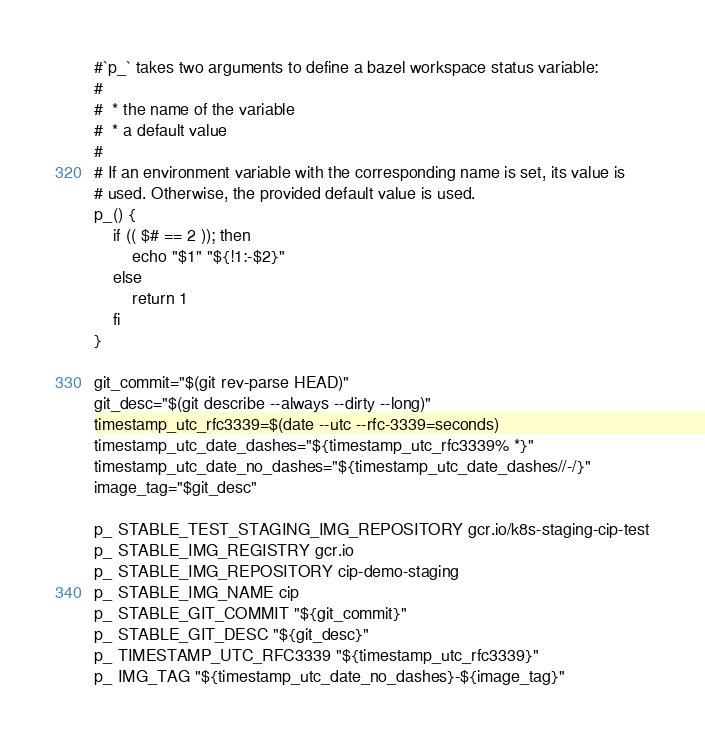<code> <loc_0><loc_0><loc_500><loc_500><_Bash_>
#`p_` takes two arguments to define a bazel workspace status variable:
#
#  * the name of the variable
#  * a default value
#
# If an environment variable with the corresponding name is set, its value is
# used. Otherwise, the provided default value is used.
p_() {
    if (( $# == 2 )); then
        echo "$1" "${!1:-$2}"
    else
        return 1
    fi
}

git_commit="$(git rev-parse HEAD)"
git_desc="$(git describe --always --dirty --long)"
timestamp_utc_rfc3339=$(date --utc --rfc-3339=seconds)
timestamp_utc_date_dashes="${timestamp_utc_rfc3339% *}"
timestamp_utc_date_no_dashes="${timestamp_utc_date_dashes//-/}"
image_tag="$git_desc"

p_ STABLE_TEST_STAGING_IMG_REPOSITORY gcr.io/k8s-staging-cip-test
p_ STABLE_IMG_REGISTRY gcr.io
p_ STABLE_IMG_REPOSITORY cip-demo-staging
p_ STABLE_IMG_NAME cip
p_ STABLE_GIT_COMMIT "${git_commit}"
p_ STABLE_GIT_DESC "${git_desc}"
p_ TIMESTAMP_UTC_RFC3339 "${timestamp_utc_rfc3339}"
p_ IMG_TAG "${timestamp_utc_date_no_dashes}-${image_tag}"
</code> 